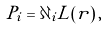<formula> <loc_0><loc_0><loc_500><loc_500>P _ { i } = \partial _ { i } L ( r ) \, ,</formula> 